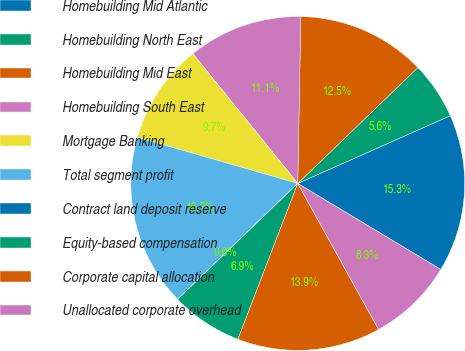Convert chart. <chart><loc_0><loc_0><loc_500><loc_500><pie_chart><fcel>Homebuilding Mid Atlantic<fcel>Homebuilding North East<fcel>Homebuilding Mid East<fcel>Homebuilding South East<fcel>Mortgage Banking<fcel>Total segment profit<fcel>Contract land deposit reserve<fcel>Equity-based compensation<fcel>Corporate capital allocation<fcel>Unallocated corporate overhead<nl><fcel>15.27%<fcel>5.56%<fcel>12.5%<fcel>11.11%<fcel>9.72%<fcel>16.66%<fcel>0.01%<fcel>6.95%<fcel>13.88%<fcel>8.34%<nl></chart> 